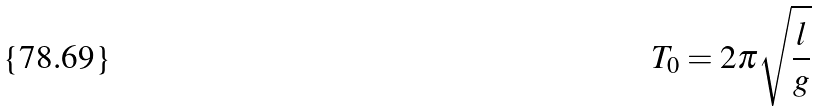Convert formula to latex. <formula><loc_0><loc_0><loc_500><loc_500>T _ { 0 } = 2 \pi \sqrt { \frac { l } { g } }</formula> 